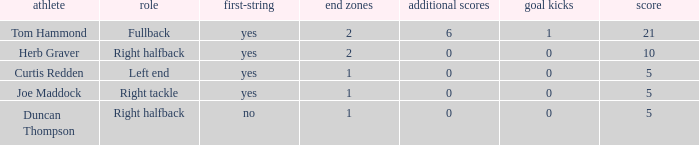Name the number of points for field goals being 1 1.0. 